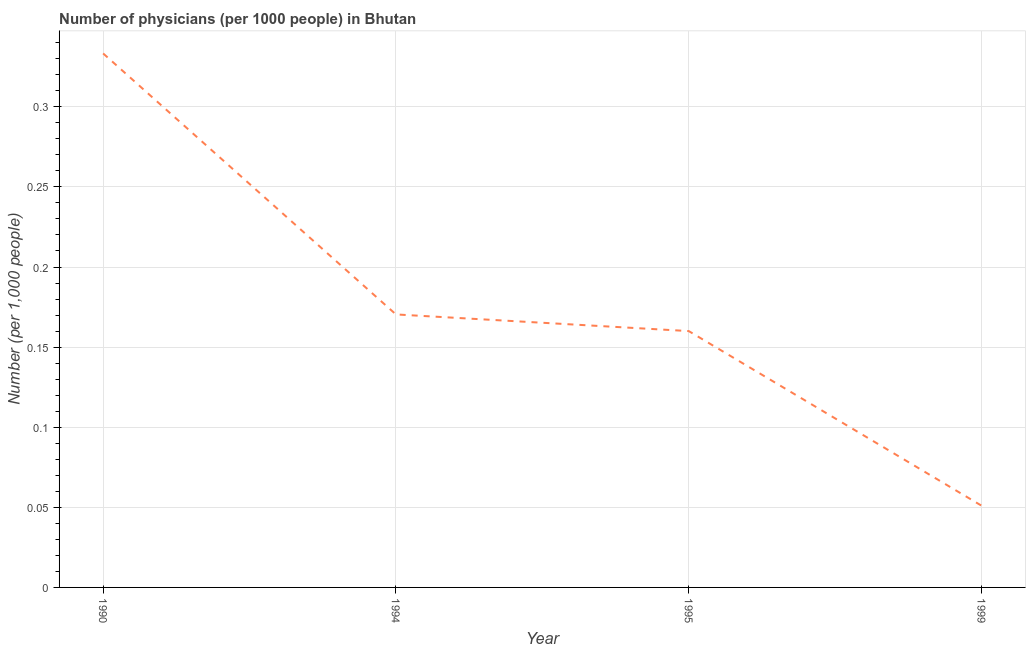What is the number of physicians in 1999?
Keep it short and to the point. 0.05. Across all years, what is the maximum number of physicians?
Make the answer very short. 0.33. Across all years, what is the minimum number of physicians?
Make the answer very short. 0.05. What is the sum of the number of physicians?
Give a very brief answer. 0.71. What is the difference between the number of physicians in 1990 and 1995?
Give a very brief answer. 0.17. What is the average number of physicians per year?
Provide a short and direct response. 0.18. What is the median number of physicians?
Offer a terse response. 0.17. In how many years, is the number of physicians greater than 0.15000000000000002 ?
Give a very brief answer. 3. What is the ratio of the number of physicians in 1994 to that in 1995?
Ensure brevity in your answer.  1.06. Is the number of physicians in 1994 less than that in 1999?
Offer a terse response. No. Is the difference between the number of physicians in 1994 and 1995 greater than the difference between any two years?
Provide a succinct answer. No. What is the difference between the highest and the second highest number of physicians?
Provide a short and direct response. 0.16. What is the difference between the highest and the lowest number of physicians?
Offer a very short reply. 0.28. How many lines are there?
Your response must be concise. 1. How many years are there in the graph?
Offer a very short reply. 4. What is the difference between two consecutive major ticks on the Y-axis?
Your answer should be very brief. 0.05. Are the values on the major ticks of Y-axis written in scientific E-notation?
Your answer should be compact. No. Does the graph contain any zero values?
Provide a succinct answer. No. What is the title of the graph?
Ensure brevity in your answer.  Number of physicians (per 1000 people) in Bhutan. What is the label or title of the Y-axis?
Offer a very short reply. Number (per 1,0 people). What is the Number (per 1,000 people) in 1990?
Offer a very short reply. 0.33. What is the Number (per 1,000 people) of 1994?
Offer a terse response. 0.17. What is the Number (per 1,000 people) in 1995?
Offer a terse response. 0.16. What is the Number (per 1,000 people) in 1999?
Make the answer very short. 0.05. What is the difference between the Number (per 1,000 people) in 1990 and 1994?
Your answer should be compact. 0.16. What is the difference between the Number (per 1,000 people) in 1990 and 1995?
Your answer should be very brief. 0.17. What is the difference between the Number (per 1,000 people) in 1990 and 1999?
Your answer should be very brief. 0.28. What is the difference between the Number (per 1,000 people) in 1994 and 1995?
Ensure brevity in your answer.  0.01. What is the difference between the Number (per 1,000 people) in 1994 and 1999?
Offer a terse response. 0.12. What is the difference between the Number (per 1,000 people) in 1995 and 1999?
Your answer should be compact. 0.11. What is the ratio of the Number (per 1,000 people) in 1990 to that in 1994?
Your answer should be very brief. 1.96. What is the ratio of the Number (per 1,000 people) in 1990 to that in 1995?
Offer a very short reply. 2.08. What is the ratio of the Number (per 1,000 people) in 1990 to that in 1999?
Ensure brevity in your answer.  6.54. What is the ratio of the Number (per 1,000 people) in 1994 to that in 1995?
Provide a succinct answer. 1.06. What is the ratio of the Number (per 1,000 people) in 1994 to that in 1999?
Provide a short and direct response. 3.34. What is the ratio of the Number (per 1,000 people) in 1995 to that in 1999?
Keep it short and to the point. 3.14. 